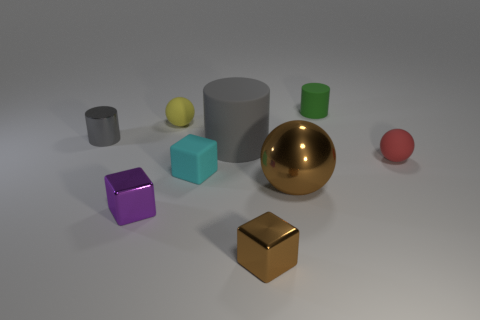Add 1 small matte objects. How many objects exist? 10 Subtract all spheres. How many objects are left? 6 Add 7 purple blocks. How many purple blocks exist? 8 Subtract 0 blue cylinders. How many objects are left? 9 Subtract all small metallic cylinders. Subtract all tiny cyan rubber cylinders. How many objects are left? 8 Add 2 red matte spheres. How many red matte spheres are left? 3 